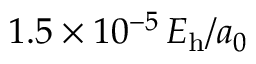<formula> <loc_0><loc_0><loc_500><loc_500>1 . 5 \times 1 0 ^ { - 5 } \, E _ { h } / a _ { 0 }</formula> 